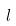Convert formula to latex. <formula><loc_0><loc_0><loc_500><loc_500>l</formula> 